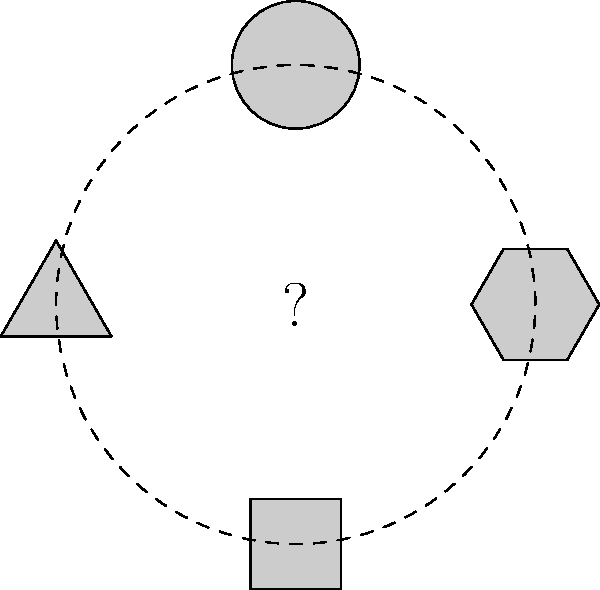In the diagram above, a pattern of geometric shapes is arranged around a central circle. Which shape should replace the question mark in the center to complete the pattern? To solve this spatial intelligence problem, we need to analyze the pattern of shapes and their arrangement:

1. Observe that there are four shapes arranged symmetrically around a central point.
2. The shapes are: hexagon, circle, triangle, and square.
3. These shapes are placed at 90-degree intervals, forming a circular pattern.
4. Notice that the shapes progress from most sides to least:
   - Hexagon (6 sides)
   - Circle (infinite sides)
   - Triangle (3 sides)
   - Square (4 sides)
5. The central shape should complete this pattern.
6. Given that we've used shapes with 6, ∞, 3, and 4 sides, the missing shape should have 5 sides to continue the progression.
7. A pentagon is the regular polygon with 5 sides, fitting between the hexagon and square in terms of number of sides.

Therefore, the shape that should replace the question mark in the center is a pentagon, completing the pattern of decreasing number of sides in a clockwise direction.
Answer: Pentagon 